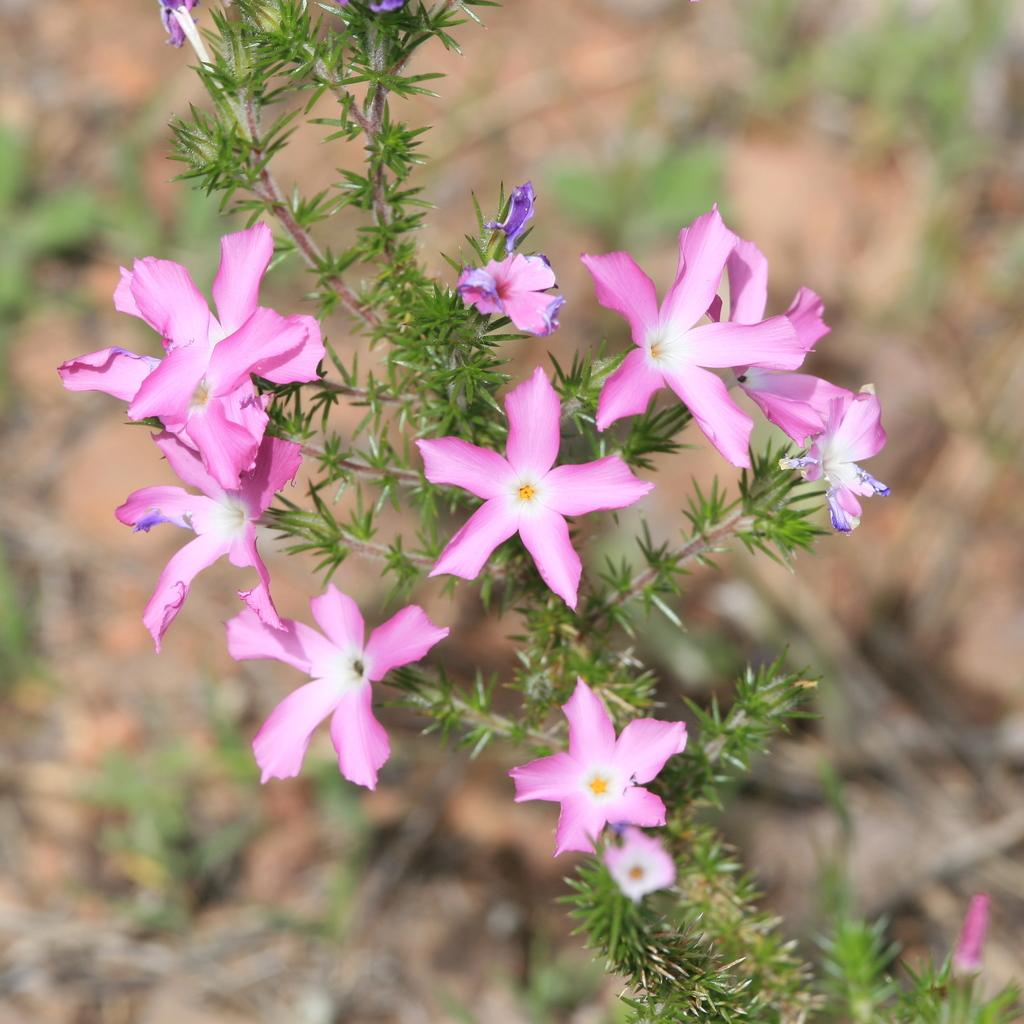What type of plant is in the image? There is a flower plant in the image. What color are the flowers on the plant? The flowers on the plant are pink. How is the background of the image depicted? The background of the plant is blurred. How many cabbages can be seen in the image? There are no cabbages present in the image; it features a flower plant with pink flowers. What type of transportation is depicted in the image? There is no transportation depicted in the image; it features a flower plant with pink flowers and a blurred background. 